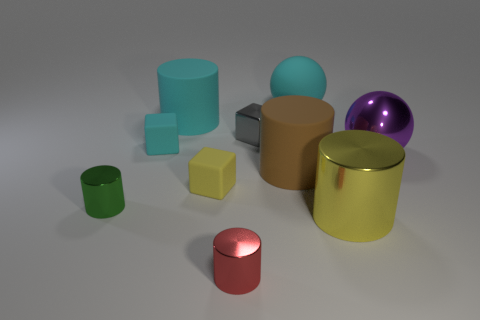Can you tell which objects have a similar finish to the shiny purple sphere? The glossy yellow cylinder has a finish reminiscent of the shiny purple sphere's surface, giving both a reflective sheen unlike the other objects depicted. 